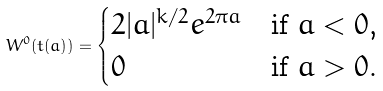<formula> <loc_0><loc_0><loc_500><loc_500>W ^ { 0 } ( t ( a ) ) = \begin{cases} 2 | a | ^ { k / 2 } e ^ { 2 \pi a } & \text {if $a<0$,} \\ 0 & \text {if $a>0$.} \end{cases}</formula> 